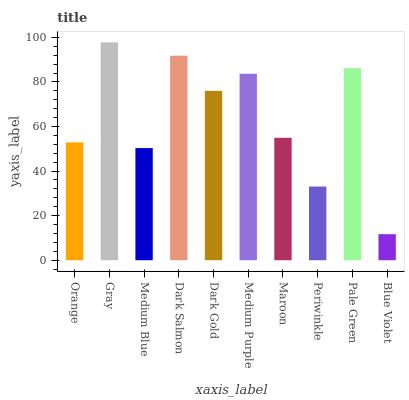Is Blue Violet the minimum?
Answer yes or no. Yes. Is Gray the maximum?
Answer yes or no. Yes. Is Medium Blue the minimum?
Answer yes or no. No. Is Medium Blue the maximum?
Answer yes or no. No. Is Gray greater than Medium Blue?
Answer yes or no. Yes. Is Medium Blue less than Gray?
Answer yes or no. Yes. Is Medium Blue greater than Gray?
Answer yes or no. No. Is Gray less than Medium Blue?
Answer yes or no. No. Is Dark Gold the high median?
Answer yes or no. Yes. Is Maroon the low median?
Answer yes or no. Yes. Is Blue Violet the high median?
Answer yes or no. No. Is Orange the low median?
Answer yes or no. No. 